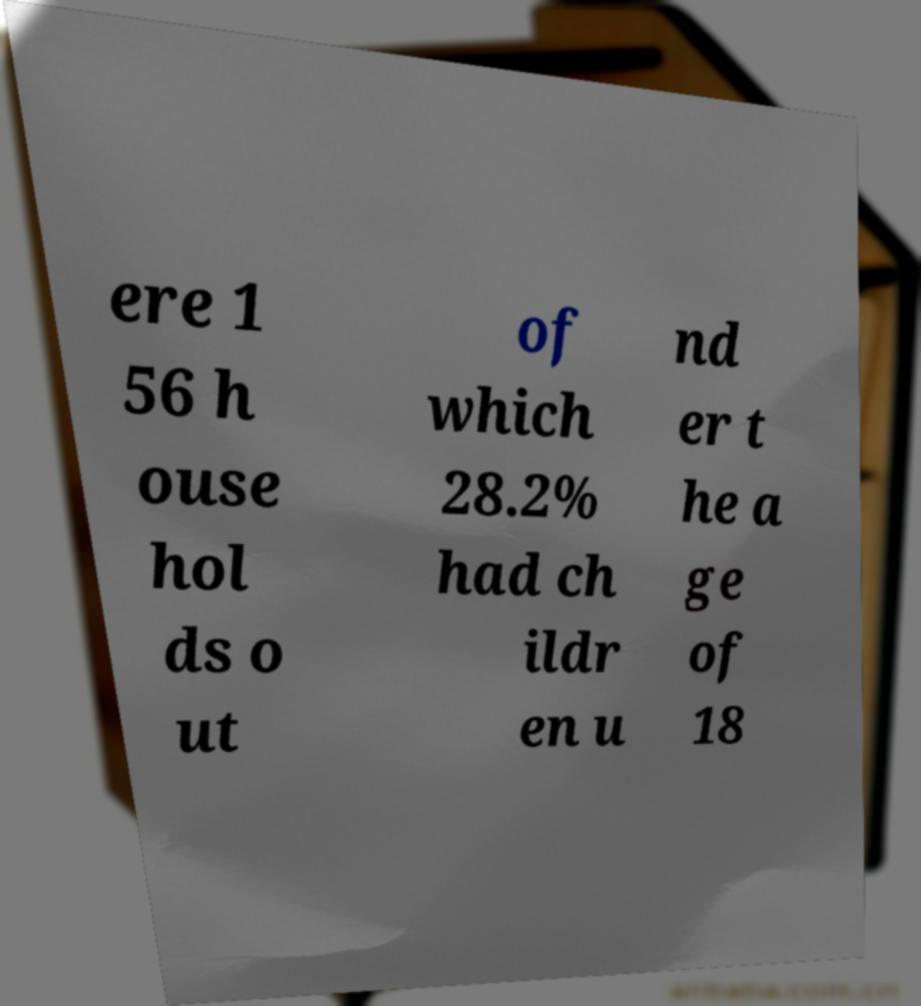Please read and relay the text visible in this image. What does it say? ere 1 56 h ouse hol ds o ut of which 28.2% had ch ildr en u nd er t he a ge of 18 